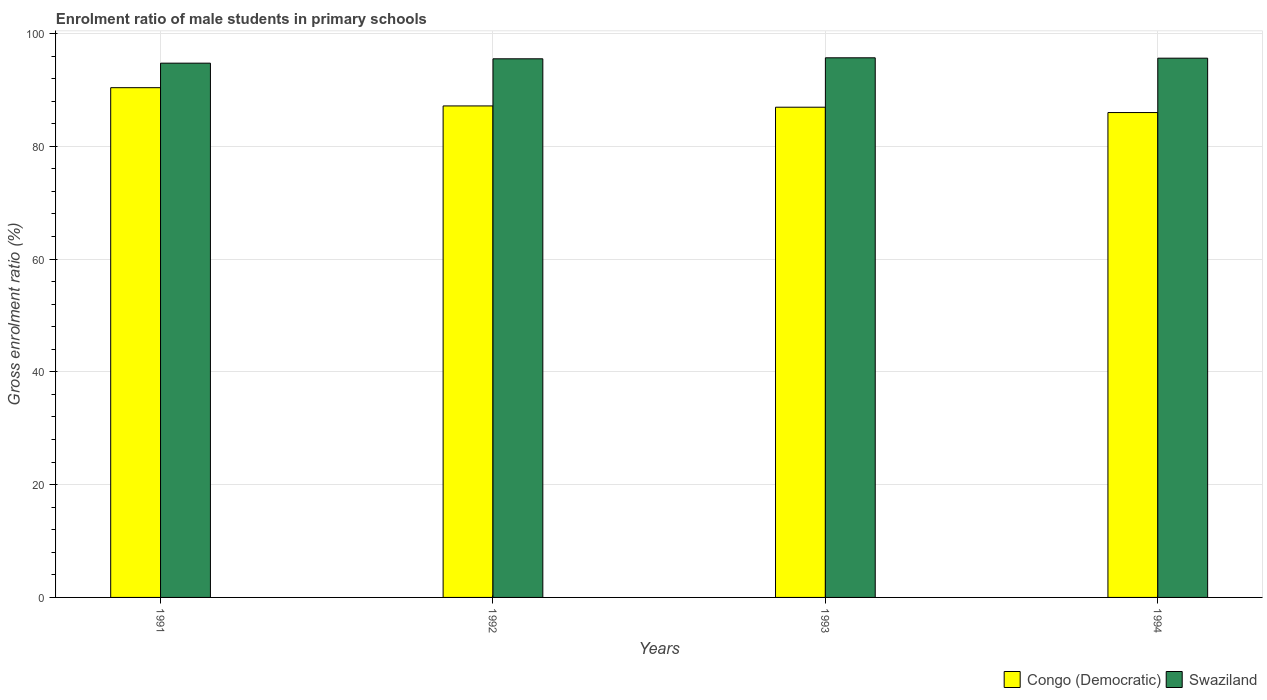How many different coloured bars are there?
Your answer should be compact. 2. Are the number of bars per tick equal to the number of legend labels?
Ensure brevity in your answer.  Yes. How many bars are there on the 2nd tick from the left?
Offer a terse response. 2. How many bars are there on the 1st tick from the right?
Give a very brief answer. 2. What is the label of the 3rd group of bars from the left?
Offer a terse response. 1993. In how many cases, is the number of bars for a given year not equal to the number of legend labels?
Keep it short and to the point. 0. What is the enrolment ratio of male students in primary schools in Swaziland in 1991?
Provide a short and direct response. 94.75. Across all years, what is the maximum enrolment ratio of male students in primary schools in Congo (Democratic)?
Offer a terse response. 90.4. Across all years, what is the minimum enrolment ratio of male students in primary schools in Swaziland?
Offer a very short reply. 94.75. What is the total enrolment ratio of male students in primary schools in Swaziland in the graph?
Offer a very short reply. 381.61. What is the difference between the enrolment ratio of male students in primary schools in Swaziland in 1993 and that in 1994?
Your response must be concise. 0.07. What is the difference between the enrolment ratio of male students in primary schools in Congo (Democratic) in 1992 and the enrolment ratio of male students in primary schools in Swaziland in 1991?
Make the answer very short. -7.58. What is the average enrolment ratio of male students in primary schools in Swaziland per year?
Offer a very short reply. 95.4. In the year 1994, what is the difference between the enrolment ratio of male students in primary schools in Swaziland and enrolment ratio of male students in primary schools in Congo (Democratic)?
Your answer should be compact. 9.64. In how many years, is the enrolment ratio of male students in primary schools in Swaziland greater than 52 %?
Offer a terse response. 4. What is the ratio of the enrolment ratio of male students in primary schools in Swaziland in 1993 to that in 1994?
Your answer should be very brief. 1. Is the difference between the enrolment ratio of male students in primary schools in Swaziland in 1992 and 1993 greater than the difference between the enrolment ratio of male students in primary schools in Congo (Democratic) in 1992 and 1993?
Offer a very short reply. No. What is the difference between the highest and the second highest enrolment ratio of male students in primary schools in Congo (Democratic)?
Offer a terse response. 3.24. What is the difference between the highest and the lowest enrolment ratio of male students in primary schools in Congo (Democratic)?
Give a very brief answer. 4.41. In how many years, is the enrolment ratio of male students in primary schools in Swaziland greater than the average enrolment ratio of male students in primary schools in Swaziland taken over all years?
Give a very brief answer. 3. Is the sum of the enrolment ratio of male students in primary schools in Swaziland in 1991 and 1992 greater than the maximum enrolment ratio of male students in primary schools in Congo (Democratic) across all years?
Your answer should be compact. Yes. What does the 2nd bar from the left in 1992 represents?
Offer a terse response. Swaziland. What does the 1st bar from the right in 1993 represents?
Give a very brief answer. Swaziland. Are all the bars in the graph horizontal?
Offer a very short reply. No. Are the values on the major ticks of Y-axis written in scientific E-notation?
Offer a very short reply. No. Does the graph contain grids?
Your answer should be compact. Yes. How many legend labels are there?
Your answer should be compact. 2. What is the title of the graph?
Your response must be concise. Enrolment ratio of male students in primary schools. Does "Euro area" appear as one of the legend labels in the graph?
Offer a terse response. No. What is the Gross enrolment ratio (%) in Congo (Democratic) in 1991?
Offer a terse response. 90.4. What is the Gross enrolment ratio (%) in Swaziland in 1991?
Provide a succinct answer. 94.75. What is the Gross enrolment ratio (%) of Congo (Democratic) in 1992?
Offer a terse response. 87.16. What is the Gross enrolment ratio (%) of Swaziland in 1992?
Your answer should be compact. 95.52. What is the Gross enrolment ratio (%) in Congo (Democratic) in 1993?
Keep it short and to the point. 86.94. What is the Gross enrolment ratio (%) in Swaziland in 1993?
Provide a succinct answer. 95.7. What is the Gross enrolment ratio (%) of Congo (Democratic) in 1994?
Keep it short and to the point. 85.99. What is the Gross enrolment ratio (%) in Swaziland in 1994?
Your response must be concise. 95.63. Across all years, what is the maximum Gross enrolment ratio (%) of Congo (Democratic)?
Provide a succinct answer. 90.4. Across all years, what is the maximum Gross enrolment ratio (%) of Swaziland?
Make the answer very short. 95.7. Across all years, what is the minimum Gross enrolment ratio (%) of Congo (Democratic)?
Offer a terse response. 85.99. Across all years, what is the minimum Gross enrolment ratio (%) in Swaziland?
Your response must be concise. 94.75. What is the total Gross enrolment ratio (%) of Congo (Democratic) in the graph?
Your response must be concise. 350.49. What is the total Gross enrolment ratio (%) in Swaziland in the graph?
Keep it short and to the point. 381.61. What is the difference between the Gross enrolment ratio (%) in Congo (Democratic) in 1991 and that in 1992?
Offer a very short reply. 3.24. What is the difference between the Gross enrolment ratio (%) in Swaziland in 1991 and that in 1992?
Provide a succinct answer. -0.77. What is the difference between the Gross enrolment ratio (%) in Congo (Democratic) in 1991 and that in 1993?
Your response must be concise. 3.47. What is the difference between the Gross enrolment ratio (%) in Swaziland in 1991 and that in 1993?
Offer a terse response. -0.95. What is the difference between the Gross enrolment ratio (%) of Congo (Democratic) in 1991 and that in 1994?
Provide a succinct answer. 4.41. What is the difference between the Gross enrolment ratio (%) in Swaziland in 1991 and that in 1994?
Make the answer very short. -0.89. What is the difference between the Gross enrolment ratio (%) in Congo (Democratic) in 1992 and that in 1993?
Your response must be concise. 0.23. What is the difference between the Gross enrolment ratio (%) in Swaziland in 1992 and that in 1993?
Keep it short and to the point. -0.18. What is the difference between the Gross enrolment ratio (%) in Congo (Democratic) in 1992 and that in 1994?
Ensure brevity in your answer.  1.17. What is the difference between the Gross enrolment ratio (%) in Swaziland in 1992 and that in 1994?
Give a very brief answer. -0.11. What is the difference between the Gross enrolment ratio (%) of Congo (Democratic) in 1993 and that in 1994?
Give a very brief answer. 0.95. What is the difference between the Gross enrolment ratio (%) of Swaziland in 1993 and that in 1994?
Provide a succinct answer. 0.07. What is the difference between the Gross enrolment ratio (%) in Congo (Democratic) in 1991 and the Gross enrolment ratio (%) in Swaziland in 1992?
Your response must be concise. -5.12. What is the difference between the Gross enrolment ratio (%) of Congo (Democratic) in 1991 and the Gross enrolment ratio (%) of Swaziland in 1993?
Ensure brevity in your answer.  -5.3. What is the difference between the Gross enrolment ratio (%) in Congo (Democratic) in 1991 and the Gross enrolment ratio (%) in Swaziland in 1994?
Provide a short and direct response. -5.23. What is the difference between the Gross enrolment ratio (%) in Congo (Democratic) in 1992 and the Gross enrolment ratio (%) in Swaziland in 1993?
Offer a very short reply. -8.54. What is the difference between the Gross enrolment ratio (%) of Congo (Democratic) in 1992 and the Gross enrolment ratio (%) of Swaziland in 1994?
Provide a short and direct response. -8.47. What is the difference between the Gross enrolment ratio (%) in Congo (Democratic) in 1993 and the Gross enrolment ratio (%) in Swaziland in 1994?
Offer a terse response. -8.7. What is the average Gross enrolment ratio (%) of Congo (Democratic) per year?
Make the answer very short. 87.62. What is the average Gross enrolment ratio (%) of Swaziland per year?
Make the answer very short. 95.4. In the year 1991, what is the difference between the Gross enrolment ratio (%) of Congo (Democratic) and Gross enrolment ratio (%) of Swaziland?
Your response must be concise. -4.35. In the year 1992, what is the difference between the Gross enrolment ratio (%) of Congo (Democratic) and Gross enrolment ratio (%) of Swaziland?
Ensure brevity in your answer.  -8.36. In the year 1993, what is the difference between the Gross enrolment ratio (%) of Congo (Democratic) and Gross enrolment ratio (%) of Swaziland?
Provide a short and direct response. -8.76. In the year 1994, what is the difference between the Gross enrolment ratio (%) in Congo (Democratic) and Gross enrolment ratio (%) in Swaziland?
Give a very brief answer. -9.64. What is the ratio of the Gross enrolment ratio (%) of Congo (Democratic) in 1991 to that in 1992?
Provide a short and direct response. 1.04. What is the ratio of the Gross enrolment ratio (%) of Congo (Democratic) in 1991 to that in 1993?
Make the answer very short. 1.04. What is the ratio of the Gross enrolment ratio (%) of Swaziland in 1991 to that in 1993?
Your answer should be compact. 0.99. What is the ratio of the Gross enrolment ratio (%) in Congo (Democratic) in 1991 to that in 1994?
Keep it short and to the point. 1.05. What is the ratio of the Gross enrolment ratio (%) in Congo (Democratic) in 1992 to that in 1994?
Your response must be concise. 1.01. What is the ratio of the Gross enrolment ratio (%) of Swaziland in 1993 to that in 1994?
Give a very brief answer. 1. What is the difference between the highest and the second highest Gross enrolment ratio (%) in Congo (Democratic)?
Your answer should be compact. 3.24. What is the difference between the highest and the second highest Gross enrolment ratio (%) of Swaziland?
Offer a very short reply. 0.07. What is the difference between the highest and the lowest Gross enrolment ratio (%) of Congo (Democratic)?
Your answer should be compact. 4.41. What is the difference between the highest and the lowest Gross enrolment ratio (%) of Swaziland?
Provide a short and direct response. 0.95. 